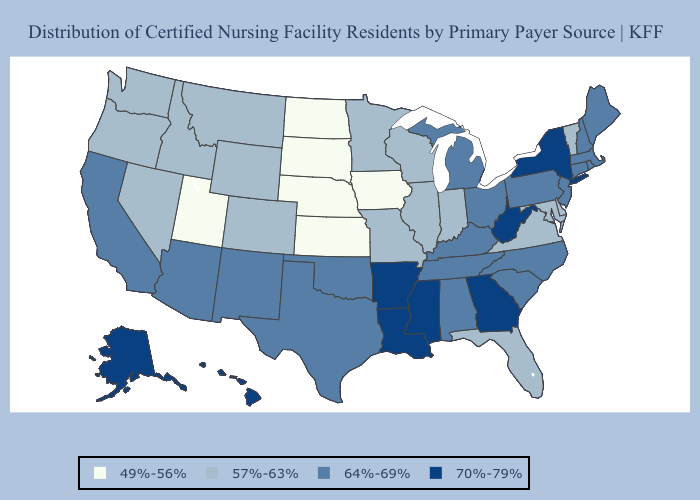Does Idaho have the lowest value in the West?
Keep it brief. No. Name the states that have a value in the range 49%-56%?
Keep it brief. Iowa, Kansas, Nebraska, North Dakota, South Dakota, Utah. Among the states that border Wyoming , which have the highest value?
Quick response, please. Colorado, Idaho, Montana. What is the lowest value in states that border Montana?
Concise answer only. 49%-56%. Does Illinois have the same value as Washington?
Quick response, please. Yes. What is the highest value in states that border Missouri?
Short answer required. 70%-79%. Among the states that border South Carolina , which have the highest value?
Quick response, please. Georgia. Name the states that have a value in the range 64%-69%?
Give a very brief answer. Alabama, Arizona, California, Connecticut, Kentucky, Maine, Massachusetts, Michigan, New Hampshire, New Jersey, New Mexico, North Carolina, Ohio, Oklahoma, Pennsylvania, Rhode Island, South Carolina, Tennessee, Texas. Which states have the highest value in the USA?
Keep it brief. Alaska, Arkansas, Georgia, Hawaii, Louisiana, Mississippi, New York, West Virginia. Does Virginia have a higher value than New Jersey?
Quick response, please. No. What is the value of Indiana?
Keep it brief. 57%-63%. Name the states that have a value in the range 70%-79%?
Short answer required. Alaska, Arkansas, Georgia, Hawaii, Louisiana, Mississippi, New York, West Virginia. What is the value of South Dakota?
Keep it brief. 49%-56%. Name the states that have a value in the range 57%-63%?
Be succinct. Colorado, Delaware, Florida, Idaho, Illinois, Indiana, Maryland, Minnesota, Missouri, Montana, Nevada, Oregon, Vermont, Virginia, Washington, Wisconsin, Wyoming. What is the value of Nevada?
Keep it brief. 57%-63%. 